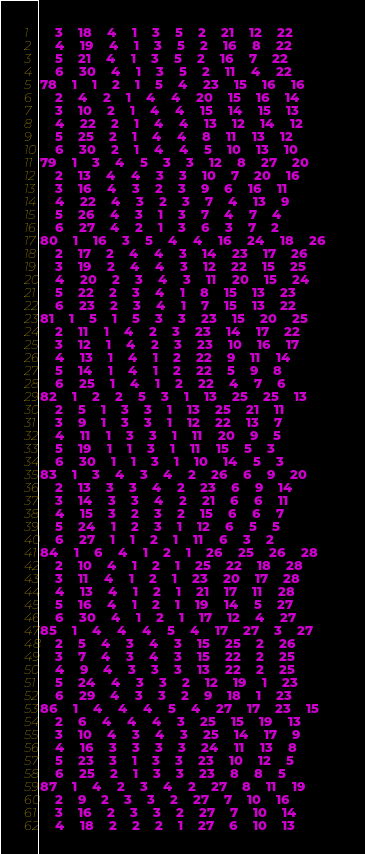<code> <loc_0><loc_0><loc_500><loc_500><_ObjectiveC_>	3	18	4	1	3	5	2	21	12	22	
	4	19	4	1	3	5	2	16	8	22	
	5	21	4	1	3	5	2	16	7	22	
	6	30	4	1	3	5	2	11	4	22	
78	1	1	2	1	5	4	23	15	16	16	
	2	4	2	1	4	4	20	15	16	14	
	3	10	2	1	4	4	15	14	15	13	
	4	22	2	1	4	4	13	12	14	12	
	5	25	2	1	4	4	8	11	13	12	
	6	30	2	1	4	4	5	10	13	10	
79	1	3	4	5	3	3	12	8	27	20	
	2	13	4	4	3	3	10	7	20	16	
	3	16	4	3	2	3	9	6	16	11	
	4	22	4	3	2	3	7	4	13	9	
	5	26	4	3	1	3	7	4	7	4	
	6	27	4	2	1	3	6	3	7	2	
80	1	16	3	5	4	4	16	24	18	26	
	2	17	2	4	4	3	14	23	17	26	
	3	19	2	4	4	3	12	22	15	25	
	4	20	2	3	4	3	11	20	15	24	
	5	22	2	3	4	1	8	15	13	23	
	6	23	2	3	4	1	7	15	13	22	
81	1	5	1	5	3	3	23	15	20	25	
	2	11	1	4	2	3	23	14	17	22	
	3	12	1	4	2	3	23	10	16	17	
	4	13	1	4	1	2	22	9	11	14	
	5	14	1	4	1	2	22	5	9	8	
	6	25	1	4	1	2	22	4	7	6	
82	1	2	2	5	3	1	13	25	25	13	
	2	5	1	3	3	1	13	25	21	11	
	3	9	1	3	3	1	12	22	13	7	
	4	11	1	3	3	1	11	20	9	5	
	5	19	1	1	3	1	11	15	5	3	
	6	30	1	1	3	1	10	14	5	3	
83	1	3	4	3	4	2	26	6	9	20	
	2	13	3	3	4	2	23	6	9	14	
	3	14	3	3	4	2	21	6	6	11	
	4	15	3	2	3	2	15	6	6	7	
	5	24	1	2	3	1	12	6	5	5	
	6	27	1	1	2	1	11	6	3	2	
84	1	6	4	1	2	1	26	25	26	28	
	2	10	4	1	2	1	25	22	18	28	
	3	11	4	1	2	1	23	20	17	28	
	4	13	4	1	2	1	21	17	11	28	
	5	16	4	1	2	1	19	14	5	27	
	6	30	4	1	2	1	17	12	4	27	
85	1	4	4	4	5	4	17	27	3	27	
	2	5	4	3	4	3	15	25	2	26	
	3	7	4	3	4	3	15	22	2	25	
	4	9	4	3	3	3	13	22	2	25	
	5	24	4	3	3	2	12	19	1	23	
	6	29	4	3	3	2	9	18	1	23	
86	1	4	4	4	5	4	27	17	23	15	
	2	6	4	4	4	3	25	15	19	13	
	3	10	4	3	4	3	25	14	17	9	
	4	16	3	3	3	3	24	11	13	8	
	5	23	3	1	3	3	23	10	12	5	
	6	25	2	1	3	3	23	8	8	5	
87	1	4	2	3	4	2	27	8	11	19	
	2	9	2	3	3	2	27	7	10	16	
	3	16	2	3	3	2	27	7	10	14	
	4	18	2	2	2	1	27	6	10	13	</code> 